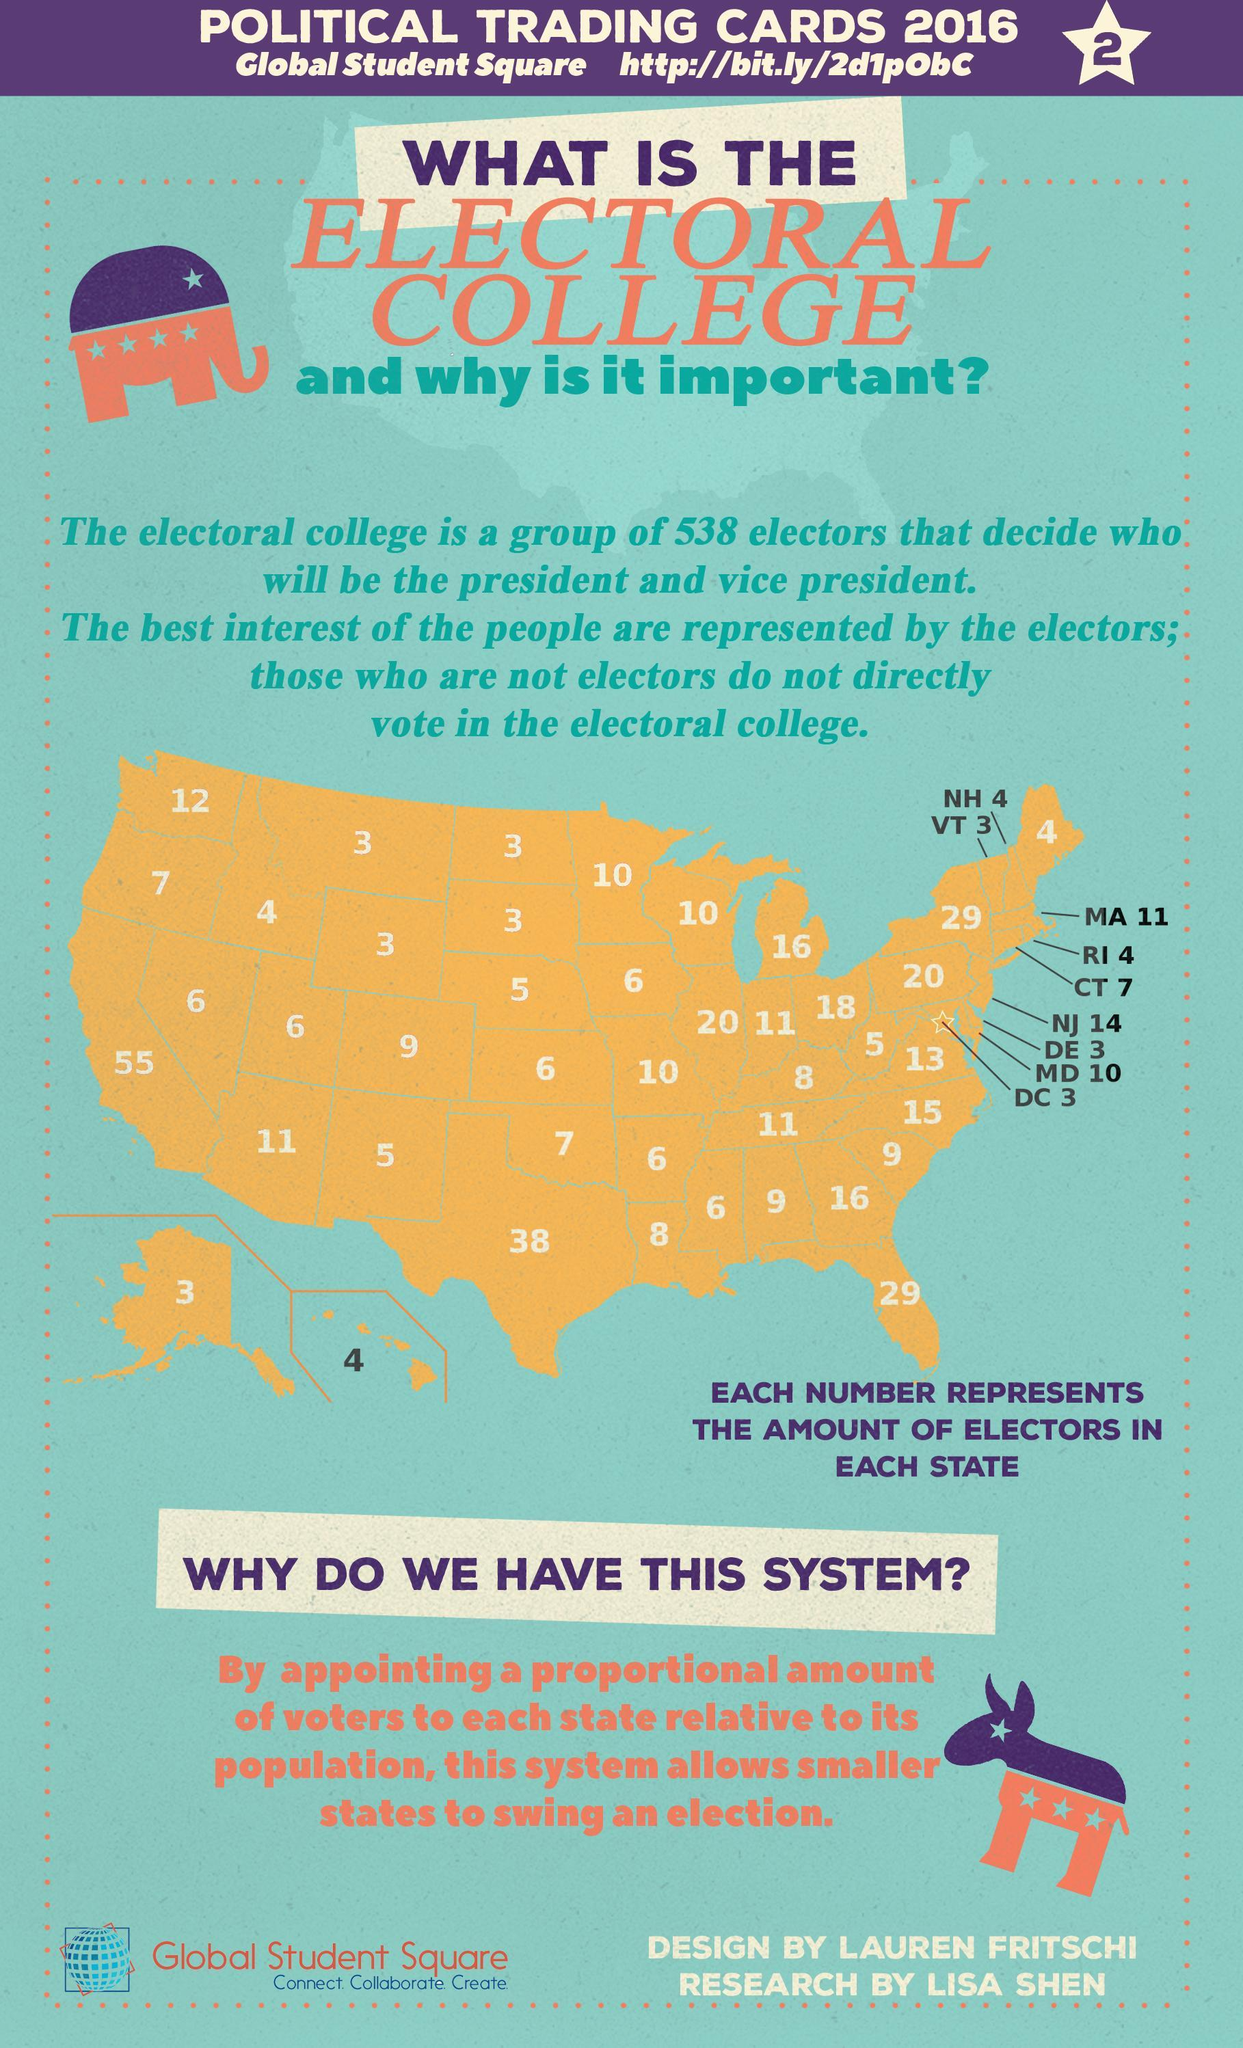How many electors are from Alaska in the US electoral college?
Answer the question with a short phrase. 3 How many electoral votes are from Hawaii in the US electoral college? 4 Which state has the most number of electors in the US electoral college - Texas, California, Florida, New Mexico? California What is the total number of electors in the US electoral college? 538 How many electors are from Florida in the US electoral college? 29 